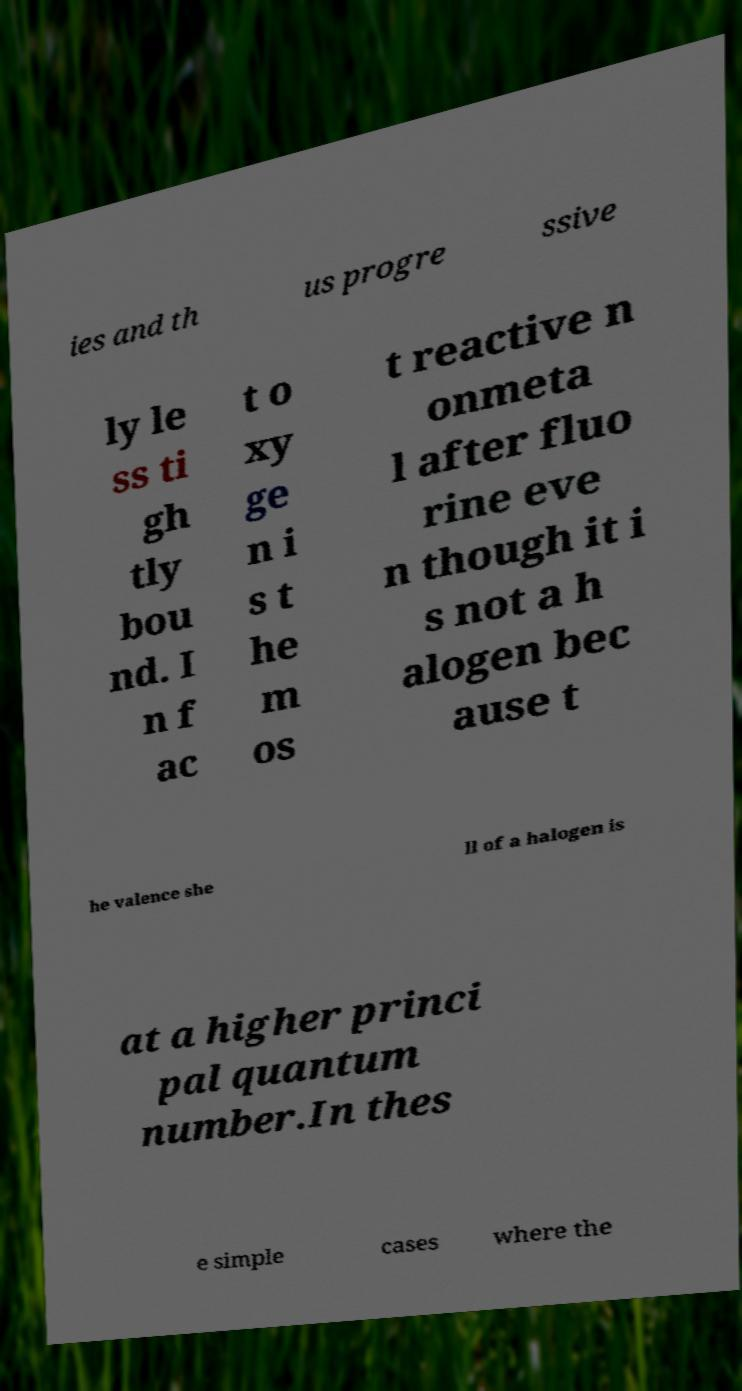What messages or text are displayed in this image? I need them in a readable, typed format. ies and th us progre ssive ly le ss ti gh tly bou nd. I n f ac t o xy ge n i s t he m os t reactive n onmeta l after fluo rine eve n though it i s not a h alogen bec ause t he valence she ll of a halogen is at a higher princi pal quantum number.In thes e simple cases where the 